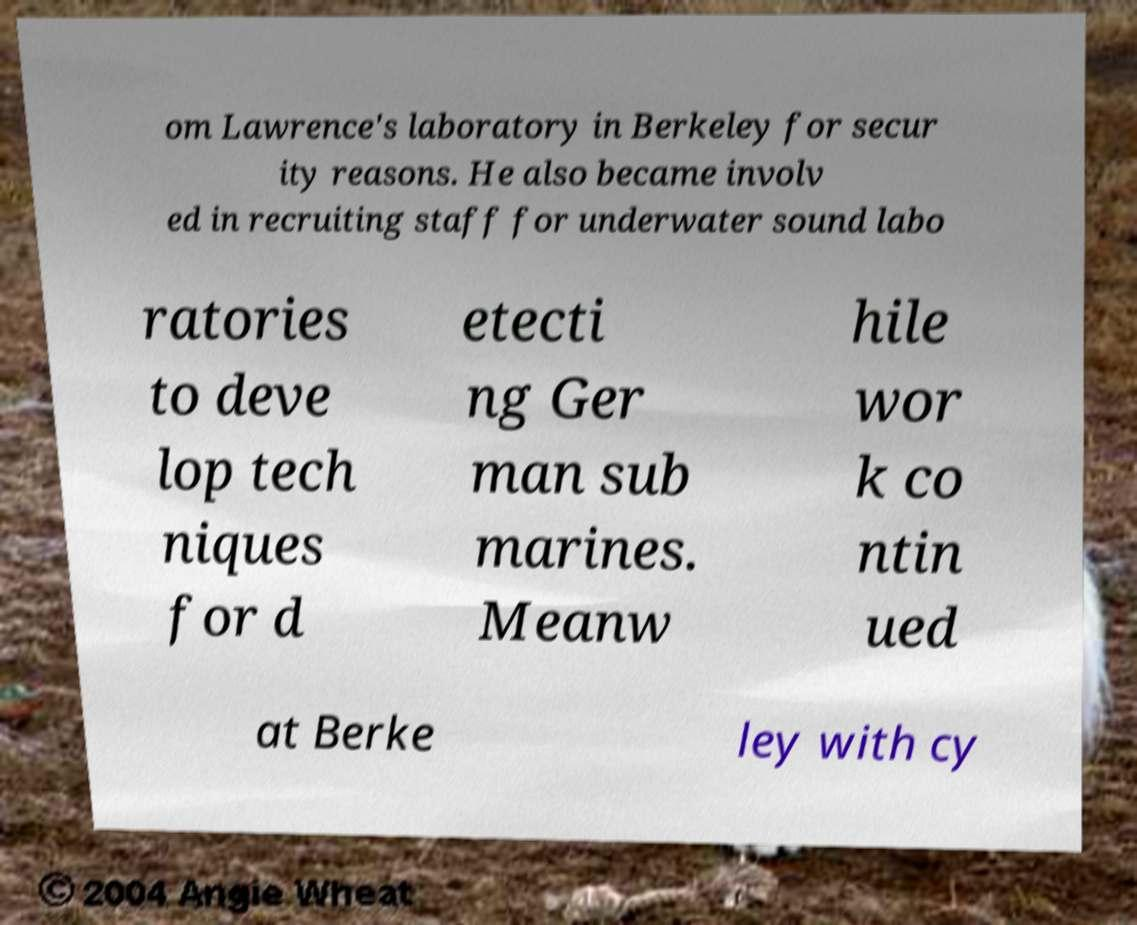Can you accurately transcribe the text from the provided image for me? om Lawrence's laboratory in Berkeley for secur ity reasons. He also became involv ed in recruiting staff for underwater sound labo ratories to deve lop tech niques for d etecti ng Ger man sub marines. Meanw hile wor k co ntin ued at Berke ley with cy 